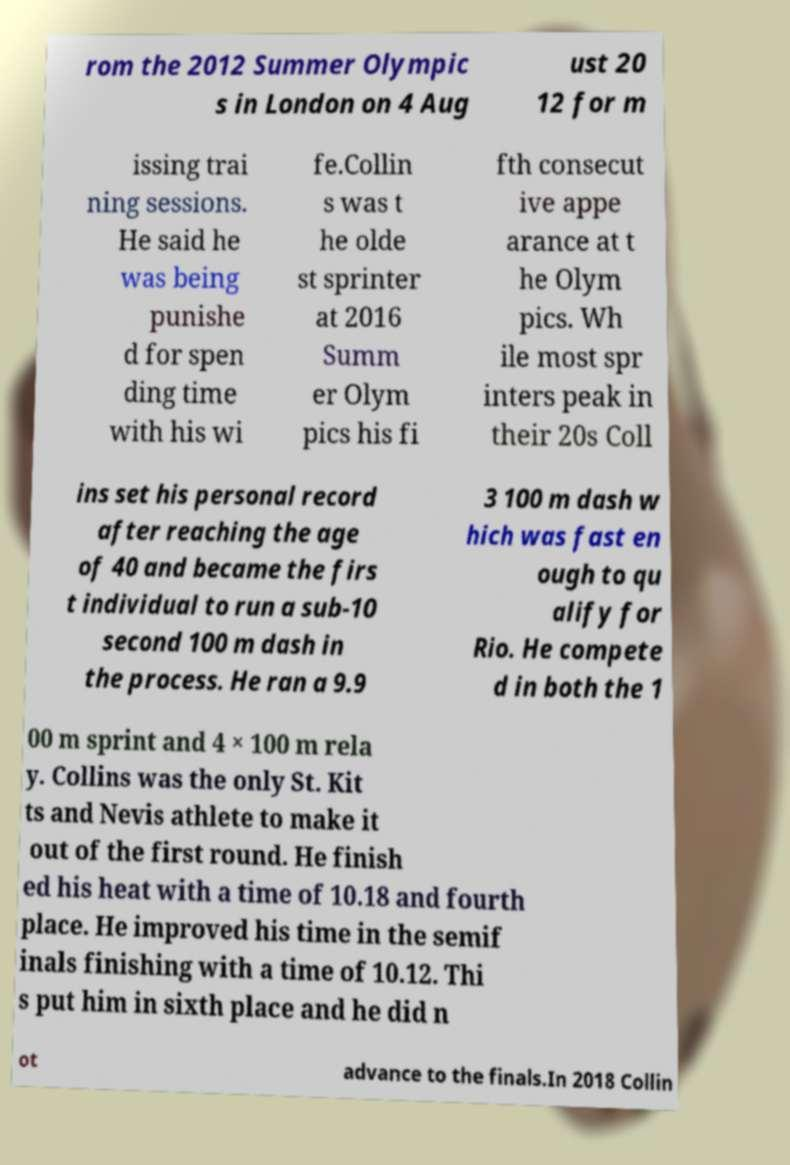For documentation purposes, I need the text within this image transcribed. Could you provide that? rom the 2012 Summer Olympic s in London on 4 Aug ust 20 12 for m issing trai ning sessions. He said he was being punishe d for spen ding time with his wi fe.Collin s was t he olde st sprinter at 2016 Summ er Olym pics his fi fth consecut ive appe arance at t he Olym pics. Wh ile most spr inters peak in their 20s Coll ins set his personal record after reaching the age of 40 and became the firs t individual to run a sub-10 second 100 m dash in the process. He ran a 9.9 3 100 m dash w hich was fast en ough to qu alify for Rio. He compete d in both the 1 00 m sprint and 4 × 100 m rela y. Collins was the only St. Kit ts and Nevis athlete to make it out of the first round. He finish ed his heat with a time of 10.18 and fourth place. He improved his time in the semif inals finishing with a time of 10.12. Thi s put him in sixth place and he did n ot advance to the finals.In 2018 Collin 